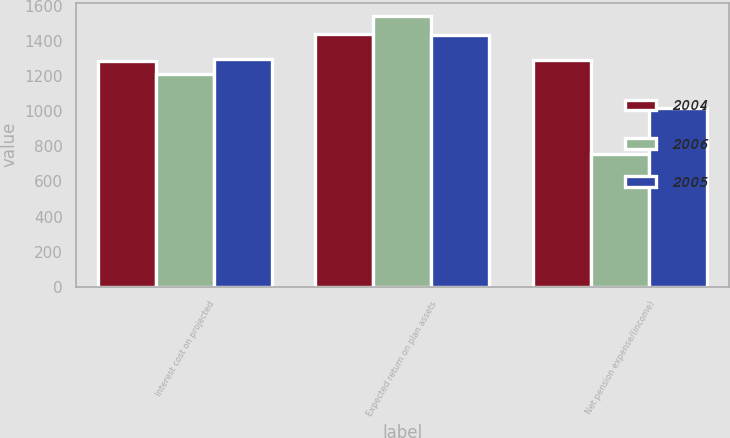Convert chart. <chart><loc_0><loc_0><loc_500><loc_500><stacked_bar_chart><ecel><fcel>Interest cost on projected<fcel>Expected return on plan assets<fcel>Net pension expense/(income)<nl><fcel>2004<fcel>1285<fcel>1439<fcel>1292<nl><fcel>2006<fcel>1213<fcel>1542<fcel>759<nl><fcel>2005<fcel>1299<fcel>1433<fcel>1018<nl></chart> 